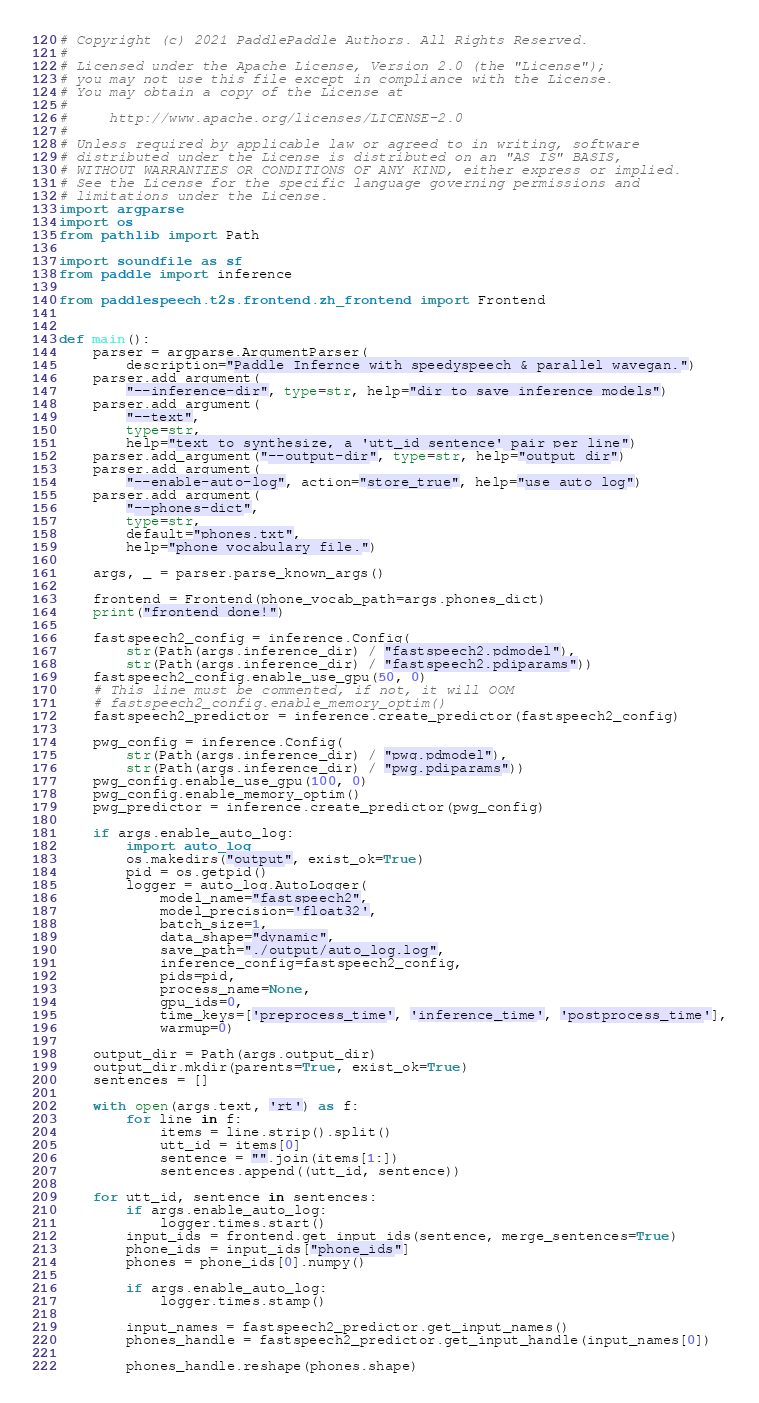<code> <loc_0><loc_0><loc_500><loc_500><_Python_># Copyright (c) 2021 PaddlePaddle Authors. All Rights Reserved.
#
# Licensed under the Apache License, Version 2.0 (the "License");
# you may not use this file except in compliance with the License.
# You may obtain a copy of the License at
#
#     http://www.apache.org/licenses/LICENSE-2.0
#
# Unless required by applicable law or agreed to in writing, software
# distributed under the License is distributed on an "AS IS" BASIS,
# WITHOUT WARRANTIES OR CONDITIONS OF ANY KIND, either express or implied.
# See the License for the specific language governing permissions and
# limitations under the License.
import argparse
import os
from pathlib import Path

import soundfile as sf
from paddle import inference

from paddlespeech.t2s.frontend.zh_frontend import Frontend


def main():
    parser = argparse.ArgumentParser(
        description="Paddle Infernce with speedyspeech & parallel wavegan.")
    parser.add_argument(
        "--inference-dir", type=str, help="dir to save inference models")
    parser.add_argument(
        "--text",
        type=str,
        help="text to synthesize, a 'utt_id sentence' pair per line")
    parser.add_argument("--output-dir", type=str, help="output dir")
    parser.add_argument(
        "--enable-auto-log", action="store_true", help="use auto log")
    parser.add_argument(
        "--phones-dict",
        type=str,
        default="phones.txt",
        help="phone vocabulary file.")

    args, _ = parser.parse_known_args()

    frontend = Frontend(phone_vocab_path=args.phones_dict)
    print("frontend done!")

    fastspeech2_config = inference.Config(
        str(Path(args.inference_dir) / "fastspeech2.pdmodel"),
        str(Path(args.inference_dir) / "fastspeech2.pdiparams"))
    fastspeech2_config.enable_use_gpu(50, 0)
    # This line must be commented, if not, it will OOM
    # fastspeech2_config.enable_memory_optim()
    fastspeech2_predictor = inference.create_predictor(fastspeech2_config)

    pwg_config = inference.Config(
        str(Path(args.inference_dir) / "pwg.pdmodel"),
        str(Path(args.inference_dir) / "pwg.pdiparams"))
    pwg_config.enable_use_gpu(100, 0)
    pwg_config.enable_memory_optim()
    pwg_predictor = inference.create_predictor(pwg_config)

    if args.enable_auto_log:
        import auto_log
        os.makedirs("output", exist_ok=True)
        pid = os.getpid()
        logger = auto_log.AutoLogger(
            model_name="fastspeech2",
            model_precision='float32',
            batch_size=1,
            data_shape="dynamic",
            save_path="./output/auto_log.log",
            inference_config=fastspeech2_config,
            pids=pid,
            process_name=None,
            gpu_ids=0,
            time_keys=['preprocess_time', 'inference_time', 'postprocess_time'],
            warmup=0)

    output_dir = Path(args.output_dir)
    output_dir.mkdir(parents=True, exist_ok=True)
    sentences = []

    with open(args.text, 'rt') as f:
        for line in f:
            items = line.strip().split()
            utt_id = items[0]
            sentence = "".join(items[1:])
            sentences.append((utt_id, sentence))

    for utt_id, sentence in sentences:
        if args.enable_auto_log:
            logger.times.start()
        input_ids = frontend.get_input_ids(sentence, merge_sentences=True)
        phone_ids = input_ids["phone_ids"]
        phones = phone_ids[0].numpy()

        if args.enable_auto_log:
            logger.times.stamp()

        input_names = fastspeech2_predictor.get_input_names()
        phones_handle = fastspeech2_predictor.get_input_handle(input_names[0])

        phones_handle.reshape(phones.shape)</code> 